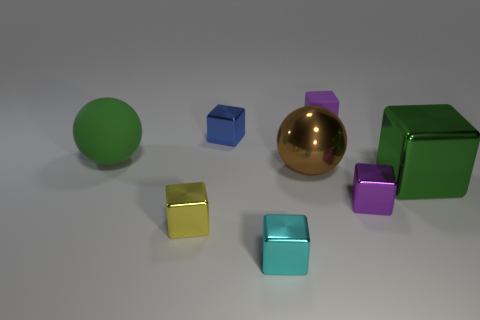Subtract all metallic blocks. How many blocks are left? 1 Subtract all purple cubes. How many cubes are left? 4 Add 1 big green blocks. How many objects exist? 9 Subtract all cyan cylinders. How many purple blocks are left? 2 Subtract 3 blocks. How many blocks are left? 3 Subtract all cubes. How many objects are left? 2 Subtract all red cubes. Subtract all yellow cylinders. How many cubes are left? 6 Subtract all brown things. Subtract all small blue shiny objects. How many objects are left? 6 Add 5 tiny shiny objects. How many tiny shiny objects are left? 9 Add 3 cyan things. How many cyan things exist? 4 